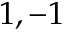<formula> <loc_0><loc_0><loc_500><loc_500>1 , - 1</formula> 